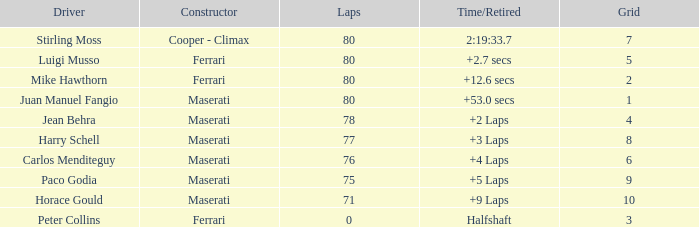What's the typical grid for a maserati with fewer than 80 laps, and a time/retired of +2 laps? 4.0. 